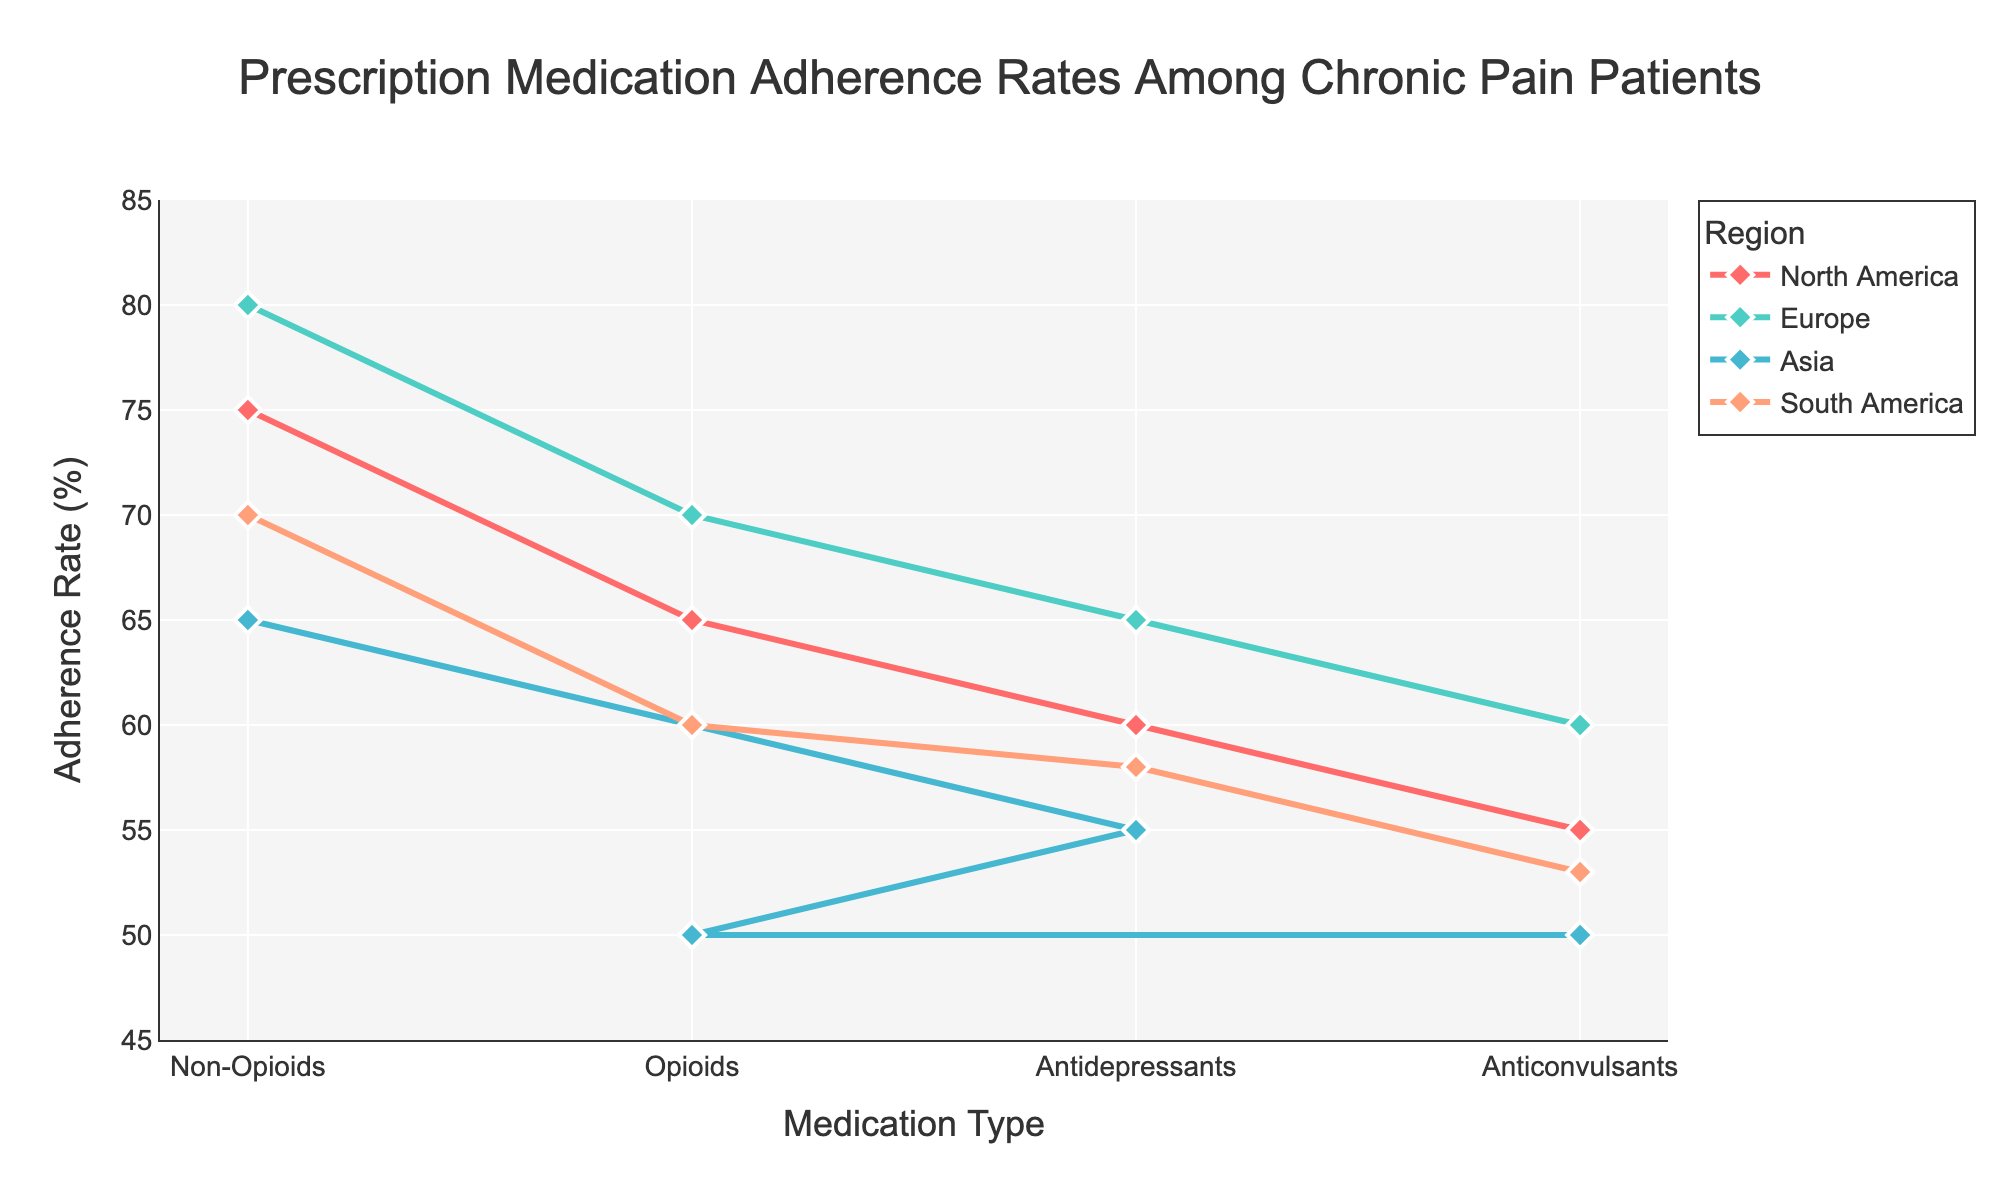What is the title of the figure? The title is prominently displayed at the top of the plot and indicates the main subject of the figure.
Answer: Prescription Medication Adherence Rates Among Chronic Pain Patients What are the labels for the x-axis and y-axis? The x-axis label indicates what the horizontal axis represents, and the y-axis label indicates what the vertical axis represents.
Answer: x-axis: Medication Type, y-axis: Adherence Rate (%) Which region has the lowest adherence rate for opioids? By examining the adherence rates for opioids across different regions, we can identify the region with the lowest rate.
Answer: Asia What is the highest adherence rate observed in the plot, and for which region and medication type? By looking at all the lines and data points, we can find the highest adherence rate and note the corresponding region and medication type.
Answer: Europe, Non-Opioids What is the adherence rate difference between Non-Opioids and Anticonvulsants in North America? Locate the adherence rates for both Non-Opioids and Anticonvulsants in North America and subtract the lower rate from the higher rate.
Answer: 20% Which medication type demonstrates the most uniform adherence rates across all regions? Compare the adherence rates for each medication type across all regions to find the one with the least variability.
Answer: Non-Opioids In which region is the adherence rate for Antidepressants higher than that for Anticonvulsants? Compare the adherence rates for Antidepressants and Anticonvulsants within each region to determine where Antidepressants have a higher rate.
Answer: North America, Europe, South America Arrange the regions in descending order based on their adherence rate for Opioids. List the regions according to their adherence rates for Opioids from the highest to the lowest.
Answer: Europe, North America, South America, Asia What is the average adherence rate for Anticonvulsants across all regions? Add up the adherence rates for Anticonvulsants from each region and divide by the number of regions to find the average.
Answer: (55+60+50+53)/4 = 54.5% How does the adherence rate for Non-Opioids compare between North America and Asia? Compare the adherence rates for Non-Opioids between North America and Asia to identify which region has a higher rate.
Answer: North America has a higher rate 